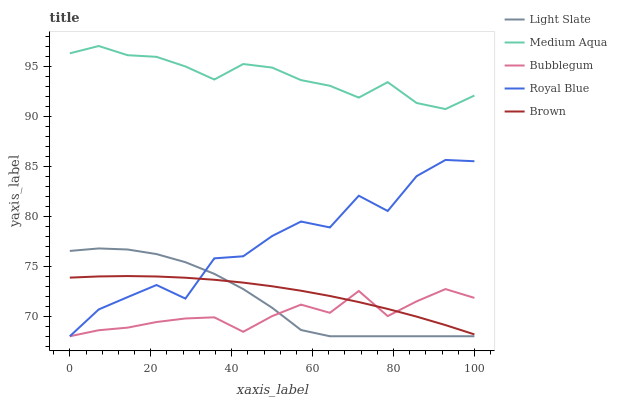Does Bubblegum have the minimum area under the curve?
Answer yes or no. Yes. Does Medium Aqua have the maximum area under the curve?
Answer yes or no. Yes. Does Royal Blue have the minimum area under the curve?
Answer yes or no. No. Does Royal Blue have the maximum area under the curve?
Answer yes or no. No. Is Brown the smoothest?
Answer yes or no. Yes. Is Royal Blue the roughest?
Answer yes or no. Yes. Is Medium Aqua the smoothest?
Answer yes or no. No. Is Medium Aqua the roughest?
Answer yes or no. No. Does Light Slate have the lowest value?
Answer yes or no. Yes. Does Medium Aqua have the lowest value?
Answer yes or no. No. Does Medium Aqua have the highest value?
Answer yes or no. Yes. Does Royal Blue have the highest value?
Answer yes or no. No. Is Bubblegum less than Medium Aqua?
Answer yes or no. Yes. Is Medium Aqua greater than Royal Blue?
Answer yes or no. Yes. Does Light Slate intersect Royal Blue?
Answer yes or no. Yes. Is Light Slate less than Royal Blue?
Answer yes or no. No. Is Light Slate greater than Royal Blue?
Answer yes or no. No. Does Bubblegum intersect Medium Aqua?
Answer yes or no. No. 